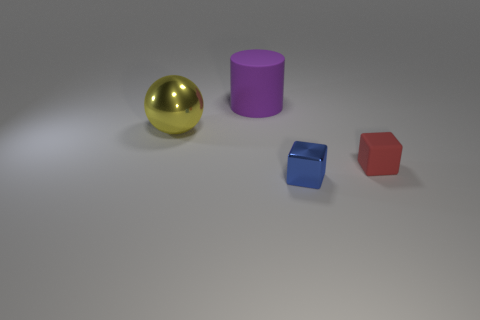How many large objects are to the right of the blue shiny cube in front of the red rubber thing?
Keep it short and to the point. 0. Does the big yellow object have the same shape as the tiny blue thing?
Keep it short and to the point. No. Are there any other things that are the same color as the large metal ball?
Provide a succinct answer. No. There is a small blue shiny object; is it the same shape as the thing behind the yellow metal object?
Keep it short and to the point. No. There is a object that is behind the metallic object to the left of the cylinder that is behind the yellow shiny thing; what is its color?
Your response must be concise. Purple. There is a metallic thing to the right of the yellow metal ball; is its shape the same as the yellow thing?
Provide a succinct answer. No. What material is the large ball?
Provide a succinct answer. Metal. There is a thing that is in front of the rubber object that is on the right side of the blue thing in front of the small red matte thing; what is its shape?
Offer a very short reply. Cube. How many other things are the same shape as the purple rubber thing?
Provide a succinct answer. 0. There is a cylinder; does it have the same color as the metallic object right of the large shiny sphere?
Your response must be concise. No. 